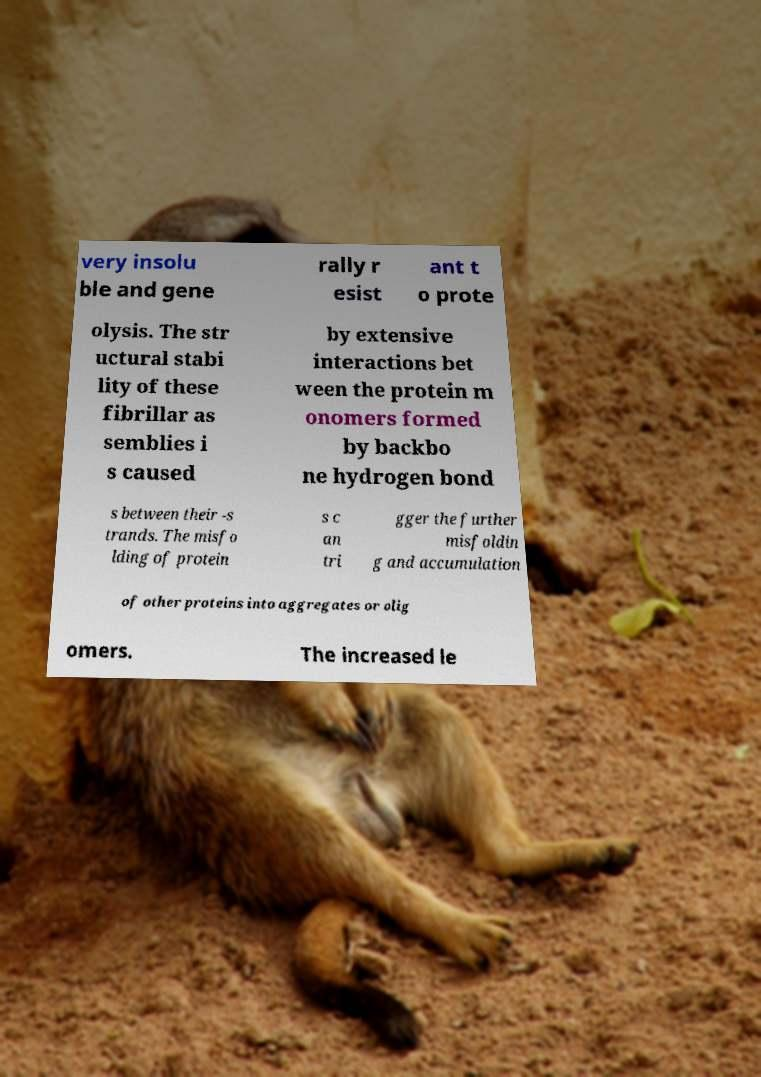For documentation purposes, I need the text within this image transcribed. Could you provide that? very insolu ble and gene rally r esist ant t o prote olysis. The str uctural stabi lity of these fibrillar as semblies i s caused by extensive interactions bet ween the protein m onomers formed by backbo ne hydrogen bond s between their -s trands. The misfo lding of protein s c an tri gger the further misfoldin g and accumulation of other proteins into aggregates or olig omers. The increased le 